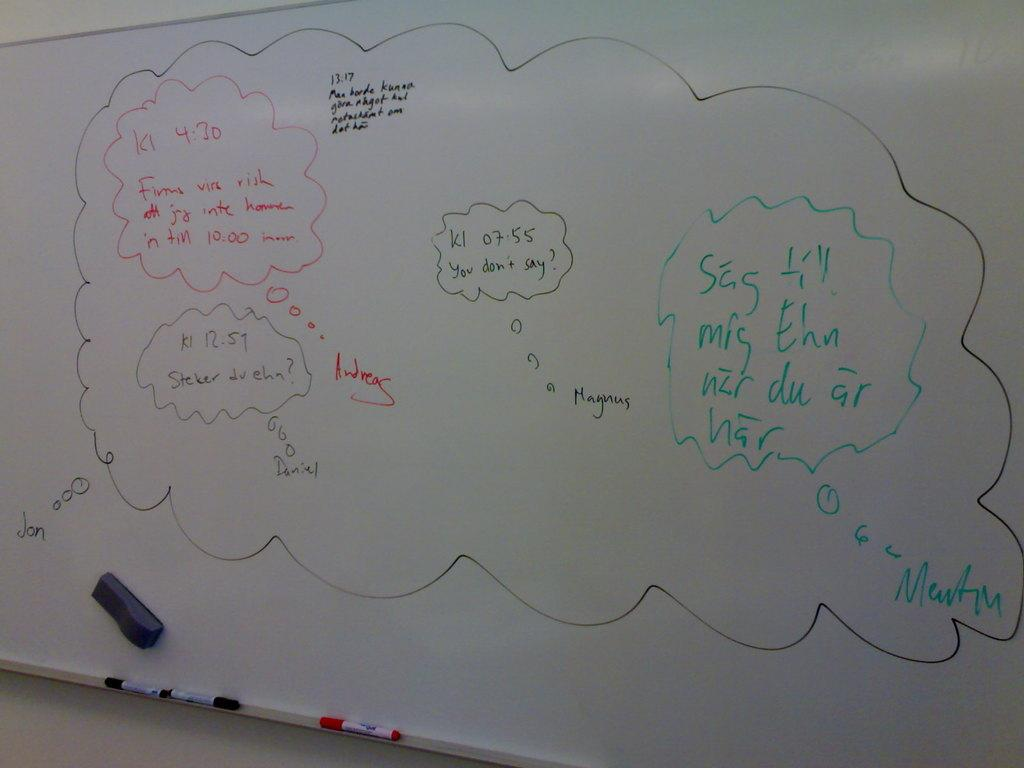<image>
Share a concise interpretation of the image provided. A white board with several ideas wrote on it including one asking "you don't say". 